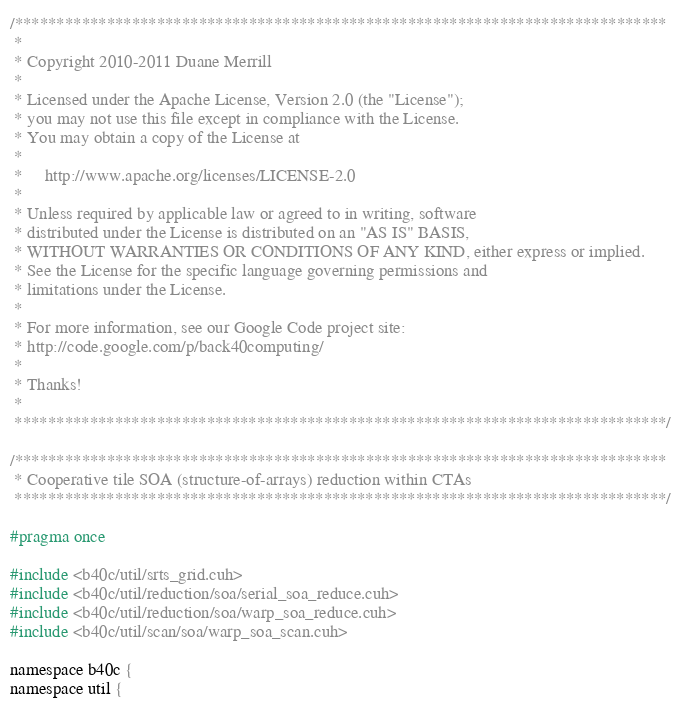Convert code to text. <code><loc_0><loc_0><loc_500><loc_500><_Cuda_>/******************************************************************************
 * 
 * Copyright 2010-2011 Duane Merrill
 * 
 * Licensed under the Apache License, Version 2.0 (the "License");
 * you may not use this file except in compliance with the License.
 * You may obtain a copy of the License at
 * 
 *     http://www.apache.org/licenses/LICENSE-2.0
 *
 * Unless required by applicable law or agreed to in writing, software
 * distributed under the License is distributed on an "AS IS" BASIS,
 * WITHOUT WARRANTIES OR CONDITIONS OF ANY KIND, either express or implied.
 * See the License for the specific language governing permissions and
 * limitations under the License. 
 * 
 * For more information, see our Google Code project site: 
 * http://code.google.com/p/back40computing/
 * 
 * Thanks!
 * 
 ******************************************************************************/

/******************************************************************************
 * Cooperative tile SOA (structure-of-arrays) reduction within CTAs
 ******************************************************************************/

#pragma once

#include <b40c/util/srts_grid.cuh>
#include <b40c/util/reduction/soa/serial_soa_reduce.cuh>
#include <b40c/util/reduction/soa/warp_soa_reduce.cuh>
#include <b40c/util/scan/soa/warp_soa_scan.cuh>

namespace b40c {
namespace util {</code> 